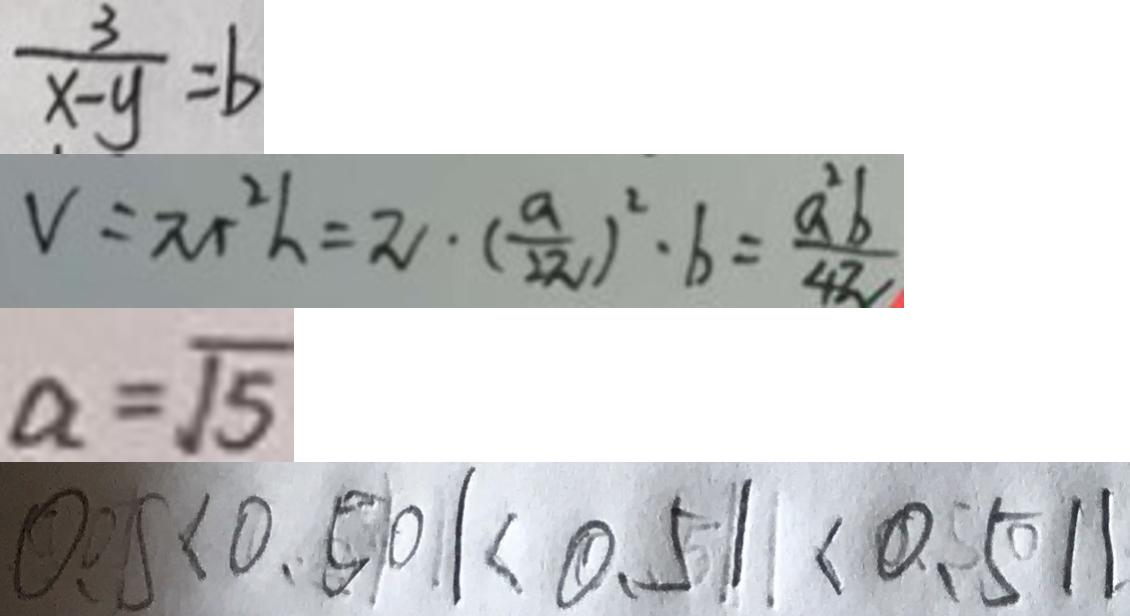<formula> <loc_0><loc_0><loc_500><loc_500>\frac { 3 } { x - y } = b 
 V = \pi r ^ { 2 } h = \pi \cdot ( \frac { a } { 2 \pi } ) ^ { 2 } \cdot b = \frac { a ^ { 2 } b } { 4 \pi } 
 a = \sqrt { 5 } 
 0 . 0 5 < 0 . 5 0 1 < 0 . 5 1 < 0 . 5 1 1</formula> 